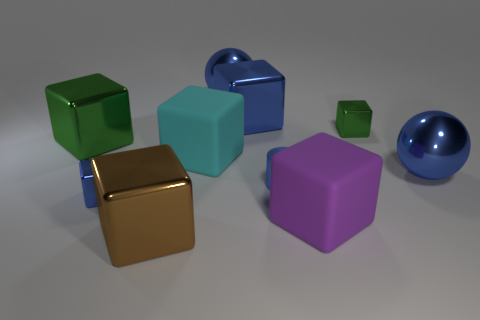Subtract all green cubes. How many cubes are left? 5 Subtract all cylinders. How many objects are left? 9 Add 9 large blue cubes. How many large blue cubes are left? 10 Add 1 green metal cubes. How many green metal cubes exist? 3 Subtract all purple cubes. How many cubes are left? 6 Subtract 0 yellow cylinders. How many objects are left? 10 Subtract 3 cubes. How many cubes are left? 4 Subtract all brown cylinders. Subtract all yellow balls. How many cylinders are left? 1 Subtract all brown balls. How many cyan cubes are left? 1 Subtract all yellow rubber cylinders. Subtract all tiny green metallic objects. How many objects are left? 9 